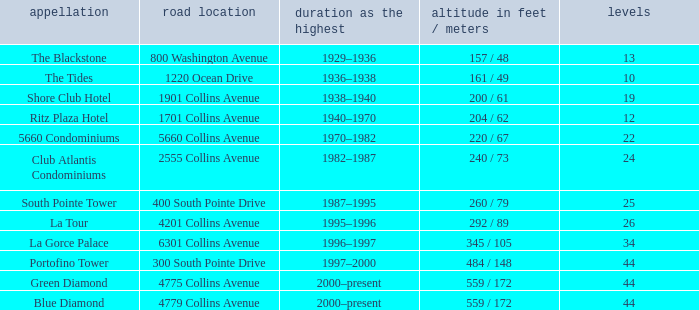What is the height of the Tides with less than 34 floors? 161 / 49. 